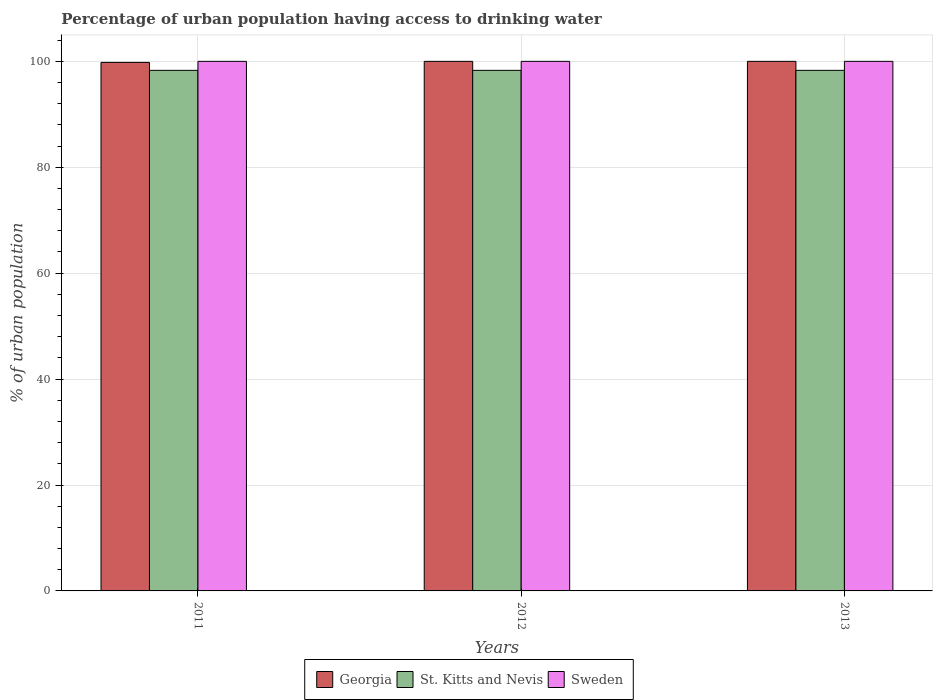How many different coloured bars are there?
Offer a very short reply. 3. How many groups of bars are there?
Offer a terse response. 3. Are the number of bars per tick equal to the number of legend labels?
Give a very brief answer. Yes. Are the number of bars on each tick of the X-axis equal?
Provide a succinct answer. Yes. How many bars are there on the 3rd tick from the left?
Keep it short and to the point. 3. How many bars are there on the 2nd tick from the right?
Provide a succinct answer. 3. What is the percentage of urban population having access to drinking water in St. Kitts and Nevis in 2012?
Offer a terse response. 98.3. Across all years, what is the maximum percentage of urban population having access to drinking water in Sweden?
Give a very brief answer. 100. Across all years, what is the minimum percentage of urban population having access to drinking water in Georgia?
Your response must be concise. 99.8. What is the total percentage of urban population having access to drinking water in St. Kitts and Nevis in the graph?
Ensure brevity in your answer.  294.9. What is the difference between the percentage of urban population having access to drinking water in Georgia in 2012 and that in 2013?
Your answer should be compact. 0. What is the difference between the percentage of urban population having access to drinking water in Georgia in 2011 and the percentage of urban population having access to drinking water in Sweden in 2012?
Your answer should be compact. -0.2. What is the average percentage of urban population having access to drinking water in St. Kitts and Nevis per year?
Provide a short and direct response. 98.3. In the year 2012, what is the difference between the percentage of urban population having access to drinking water in Georgia and percentage of urban population having access to drinking water in St. Kitts and Nevis?
Your answer should be very brief. 1.7. Is the percentage of urban population having access to drinking water in Sweden in 2012 less than that in 2013?
Your response must be concise. No. What is the difference between the highest and the lowest percentage of urban population having access to drinking water in Georgia?
Provide a succinct answer. 0.2. What does the 2nd bar from the left in 2012 represents?
Ensure brevity in your answer.  St. Kitts and Nevis. Is it the case that in every year, the sum of the percentage of urban population having access to drinking water in Sweden and percentage of urban population having access to drinking water in St. Kitts and Nevis is greater than the percentage of urban population having access to drinking water in Georgia?
Your answer should be compact. Yes. How many bars are there?
Provide a succinct answer. 9. What is the difference between two consecutive major ticks on the Y-axis?
Provide a succinct answer. 20. Does the graph contain any zero values?
Offer a very short reply. No. Does the graph contain grids?
Provide a short and direct response. Yes. Where does the legend appear in the graph?
Offer a terse response. Bottom center. How many legend labels are there?
Your answer should be very brief. 3. What is the title of the graph?
Provide a short and direct response. Percentage of urban population having access to drinking water. What is the label or title of the Y-axis?
Your answer should be compact. % of urban population. What is the % of urban population of Georgia in 2011?
Make the answer very short. 99.8. What is the % of urban population of St. Kitts and Nevis in 2011?
Provide a succinct answer. 98.3. What is the % of urban population of Georgia in 2012?
Provide a short and direct response. 100. What is the % of urban population of St. Kitts and Nevis in 2012?
Provide a short and direct response. 98.3. What is the % of urban population in St. Kitts and Nevis in 2013?
Your answer should be compact. 98.3. Across all years, what is the maximum % of urban population of Georgia?
Your answer should be compact. 100. Across all years, what is the maximum % of urban population in St. Kitts and Nevis?
Ensure brevity in your answer.  98.3. Across all years, what is the maximum % of urban population of Sweden?
Your answer should be very brief. 100. Across all years, what is the minimum % of urban population of Georgia?
Provide a succinct answer. 99.8. Across all years, what is the minimum % of urban population in St. Kitts and Nevis?
Give a very brief answer. 98.3. What is the total % of urban population in Georgia in the graph?
Provide a succinct answer. 299.8. What is the total % of urban population in St. Kitts and Nevis in the graph?
Ensure brevity in your answer.  294.9. What is the total % of urban population in Sweden in the graph?
Give a very brief answer. 300. What is the difference between the % of urban population in Georgia in 2011 and that in 2012?
Offer a very short reply. -0.2. What is the difference between the % of urban population in St. Kitts and Nevis in 2011 and that in 2012?
Offer a terse response. 0. What is the difference between the % of urban population in Sweden in 2011 and that in 2012?
Your response must be concise. 0. What is the difference between the % of urban population in Georgia in 2011 and that in 2013?
Your answer should be very brief. -0.2. What is the difference between the % of urban population of St. Kitts and Nevis in 2012 and that in 2013?
Your answer should be very brief. 0. What is the difference between the % of urban population of Georgia in 2011 and the % of urban population of St. Kitts and Nevis in 2012?
Ensure brevity in your answer.  1.5. What is the difference between the % of urban population of St. Kitts and Nevis in 2011 and the % of urban population of Sweden in 2012?
Give a very brief answer. -1.7. What is the difference between the % of urban population of St. Kitts and Nevis in 2011 and the % of urban population of Sweden in 2013?
Give a very brief answer. -1.7. What is the difference between the % of urban population of St. Kitts and Nevis in 2012 and the % of urban population of Sweden in 2013?
Give a very brief answer. -1.7. What is the average % of urban population of Georgia per year?
Offer a terse response. 99.93. What is the average % of urban population of St. Kitts and Nevis per year?
Keep it short and to the point. 98.3. In the year 2011, what is the difference between the % of urban population in Georgia and % of urban population in St. Kitts and Nevis?
Provide a short and direct response. 1.5. In the year 2012, what is the difference between the % of urban population in Georgia and % of urban population in St. Kitts and Nevis?
Offer a very short reply. 1.7. In the year 2012, what is the difference between the % of urban population of Georgia and % of urban population of Sweden?
Your answer should be very brief. 0. In the year 2013, what is the difference between the % of urban population of St. Kitts and Nevis and % of urban population of Sweden?
Provide a succinct answer. -1.7. What is the ratio of the % of urban population in Georgia in 2011 to that in 2012?
Offer a terse response. 1. What is the ratio of the % of urban population of St. Kitts and Nevis in 2011 to that in 2012?
Give a very brief answer. 1. What is the ratio of the % of urban population in Georgia in 2011 to that in 2013?
Offer a very short reply. 1. What is the ratio of the % of urban population in St. Kitts and Nevis in 2011 to that in 2013?
Provide a short and direct response. 1. What is the ratio of the % of urban population in Sweden in 2012 to that in 2013?
Your answer should be very brief. 1. What is the difference between the highest and the second highest % of urban population in Georgia?
Give a very brief answer. 0. What is the difference between the highest and the second highest % of urban population of St. Kitts and Nevis?
Provide a short and direct response. 0. What is the difference between the highest and the lowest % of urban population of Georgia?
Offer a very short reply. 0.2. What is the difference between the highest and the lowest % of urban population of St. Kitts and Nevis?
Your answer should be compact. 0. What is the difference between the highest and the lowest % of urban population of Sweden?
Provide a short and direct response. 0. 